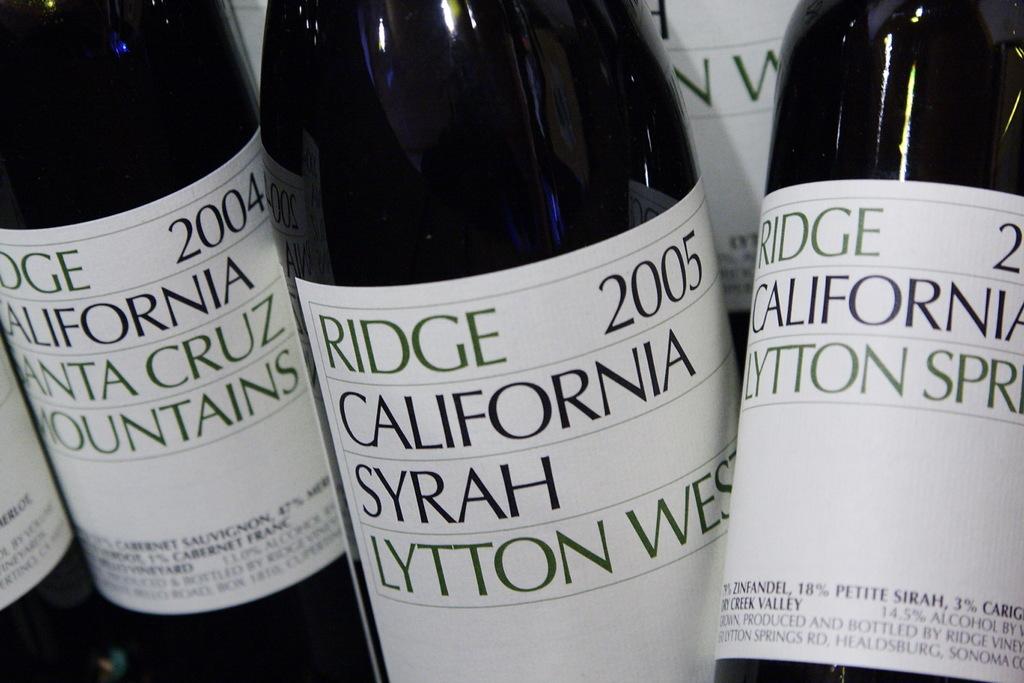What year was this red wine made?
Offer a very short reply. 2005. 